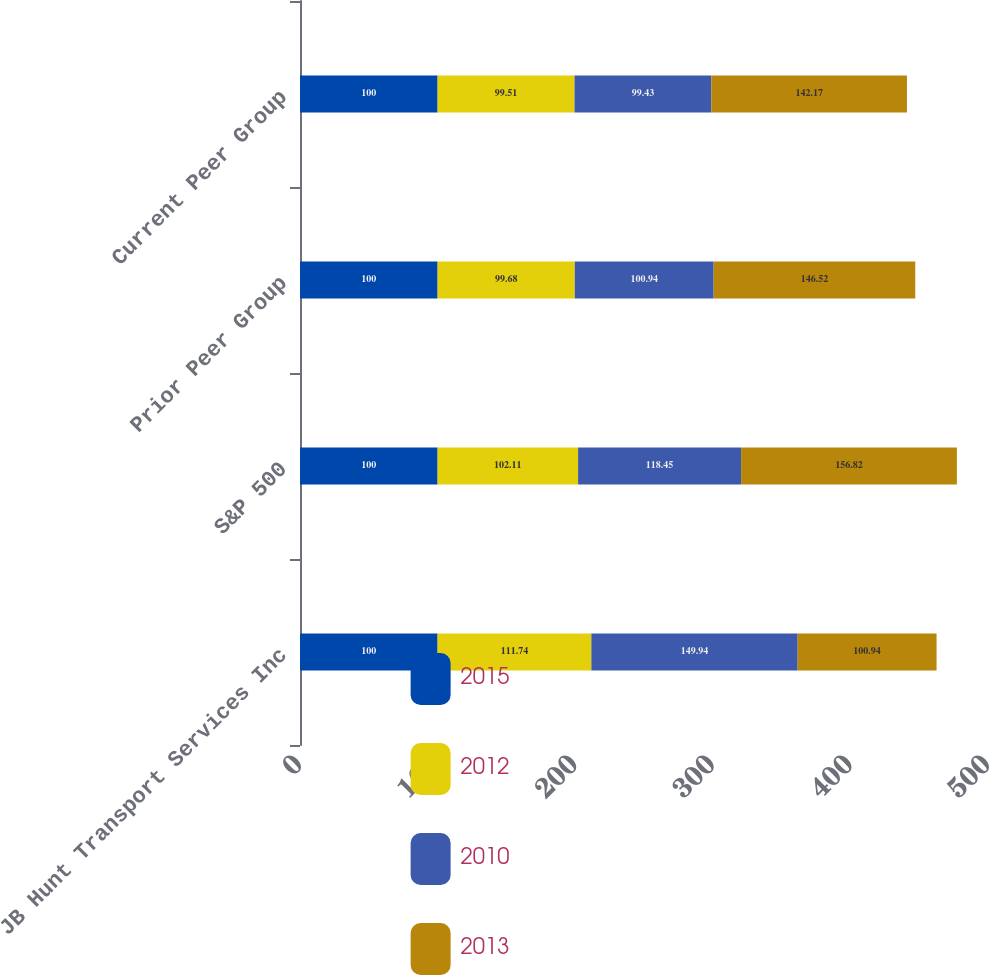Convert chart to OTSL. <chart><loc_0><loc_0><loc_500><loc_500><stacked_bar_chart><ecel><fcel>JB Hunt Transport Services Inc<fcel>S&P 500<fcel>Prior Peer Group<fcel>Current Peer Group<nl><fcel>2015<fcel>100<fcel>100<fcel>100<fcel>100<nl><fcel>2012<fcel>111.74<fcel>102.11<fcel>99.68<fcel>99.51<nl><fcel>2010<fcel>149.94<fcel>118.45<fcel>100.94<fcel>99.43<nl><fcel>2013<fcel>100.94<fcel>156.82<fcel>146.52<fcel>142.17<nl></chart> 